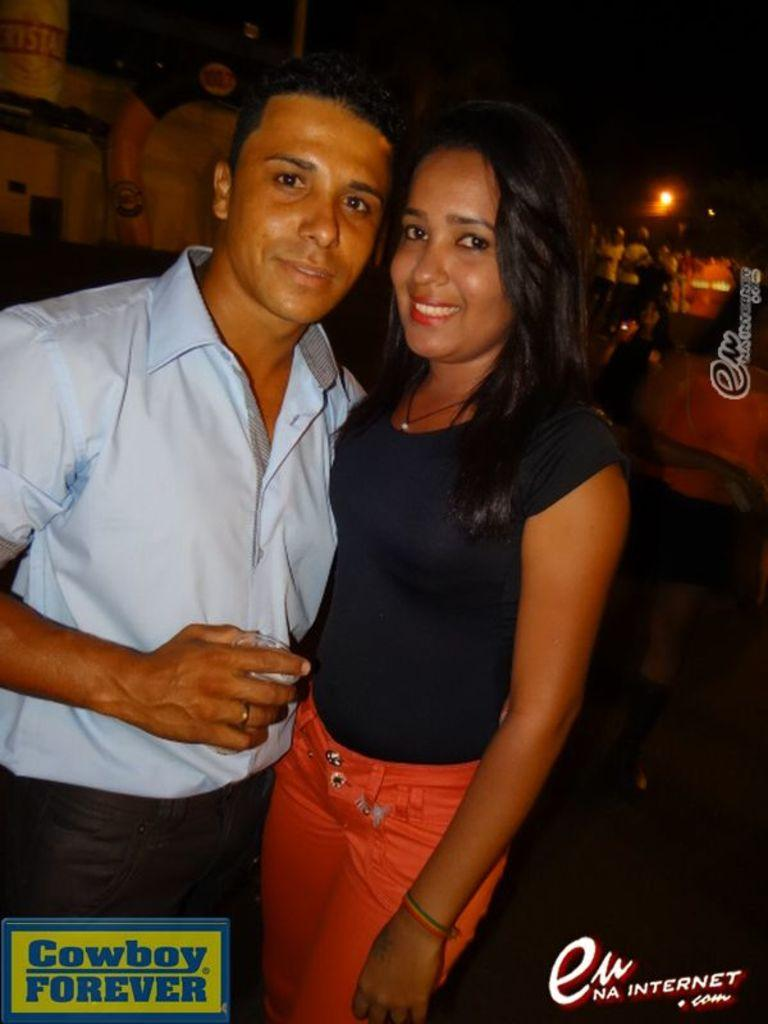Who are the two people in the center of the image? There is a man and a woman in the center of the image. What is the surface beneath the man and woman? The man and woman are standing on the ground. What can be seen in the background of the image? There is light visible in the background of the image, as well as persons and at least one building. What type of paste is being used to create the wilderness scene in the image? There is no wilderness scene or paste present in the image; it features a man and a woman standing on the ground with a background that includes light, persons, and a building. 